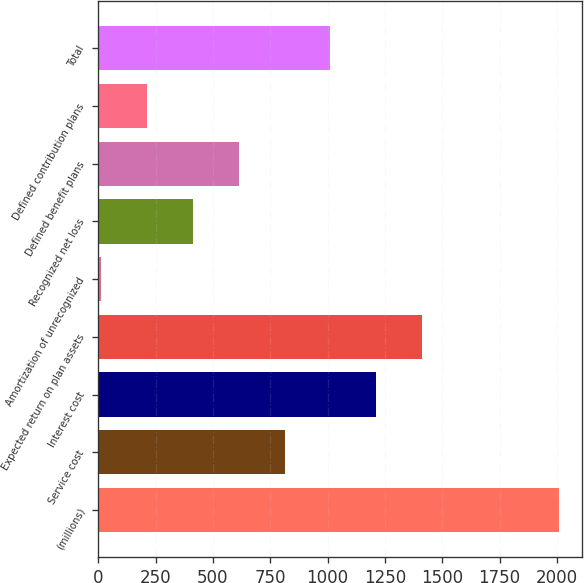Convert chart to OTSL. <chart><loc_0><loc_0><loc_500><loc_500><bar_chart><fcel>(millions)<fcel>Service cost<fcel>Interest cost<fcel>Expected return on plan assets<fcel>Amortization of unrecognized<fcel>Recognized net loss<fcel>Defined benefit plans<fcel>Defined contribution plans<fcel>Total<nl><fcel>2010<fcel>812.4<fcel>1211.6<fcel>1411.2<fcel>14<fcel>413.2<fcel>612.8<fcel>213.6<fcel>1012<nl></chart> 